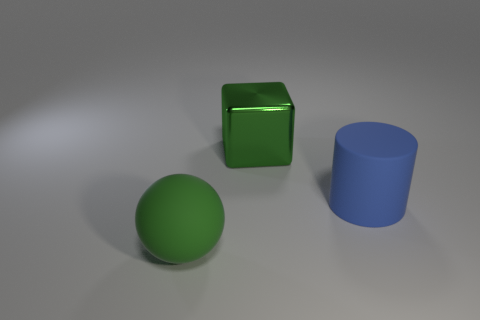Add 3 green metal objects. How many objects exist? 6 Add 1 tiny yellow rubber things. How many tiny yellow rubber things exist? 1 Subtract 0 gray spheres. How many objects are left? 3 Subtract all cylinders. How many objects are left? 2 Subtract all green metallic cubes. Subtract all tiny blue cubes. How many objects are left? 2 Add 2 rubber cylinders. How many rubber cylinders are left? 3 